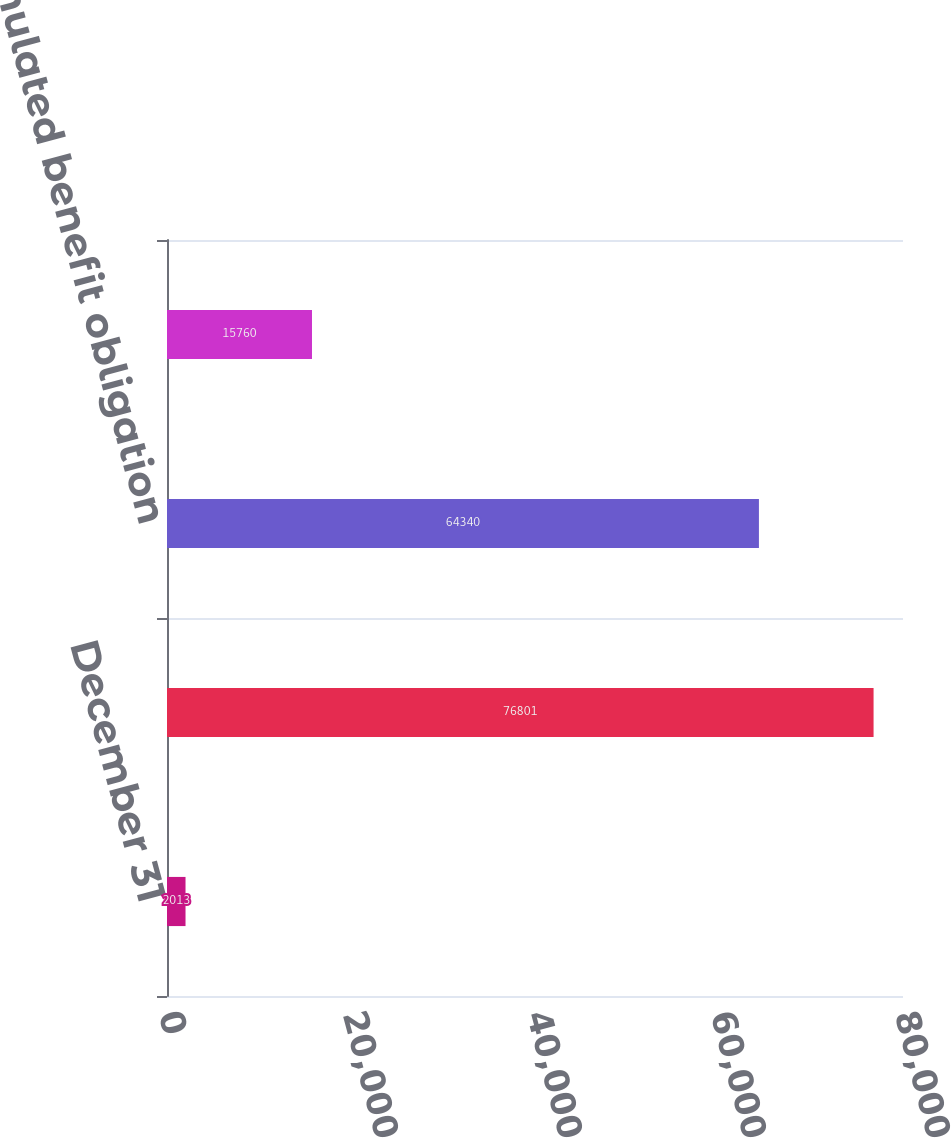Convert chart to OTSL. <chart><loc_0><loc_0><loc_500><loc_500><bar_chart><fcel>December 31<fcel>Projected benefit obligation<fcel>Accumulated benefit obligation<fcel>Fair value of plan assets<nl><fcel>2013<fcel>76801<fcel>64340<fcel>15760<nl></chart> 